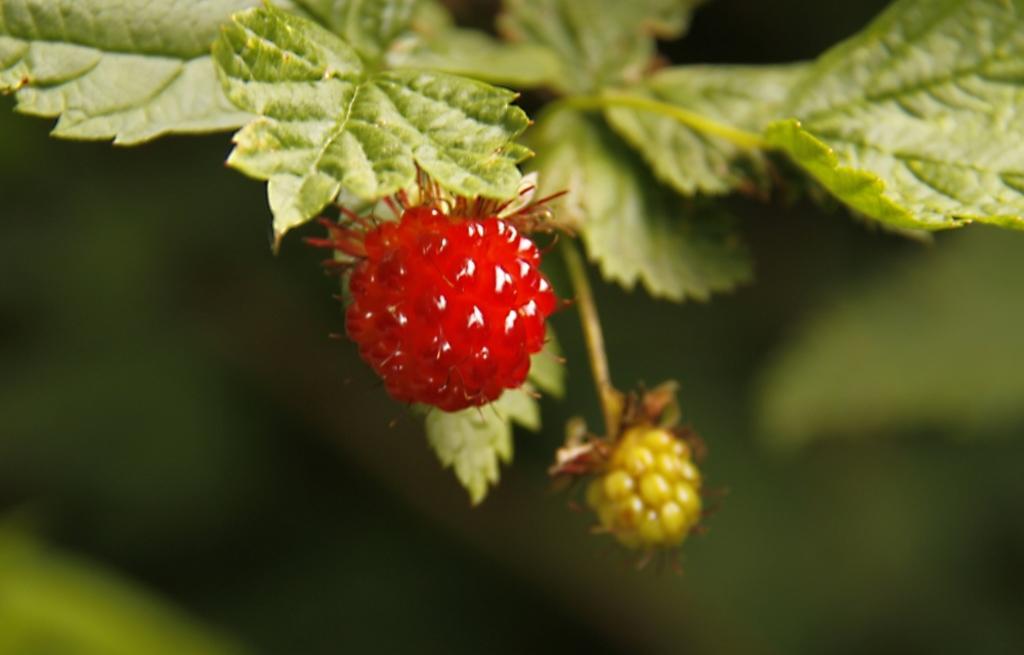Describe this image in one or two sentences. In this picture, we see a tree which has the berries. These berries are in red and green color. In the background, it is green in color. This picture is blurred in the background. 